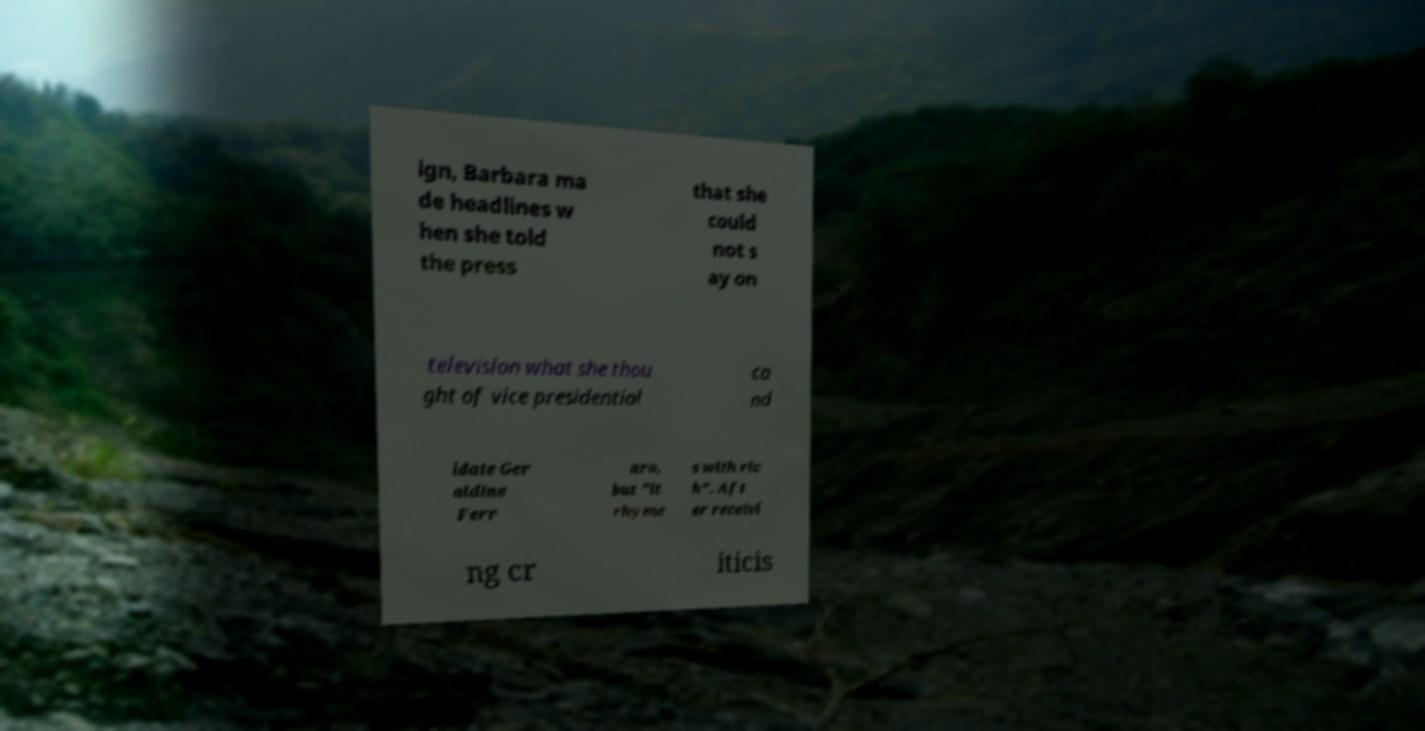Could you extract and type out the text from this image? ign, Barbara ma de headlines w hen she told the press that she could not s ay on television what she thou ght of vice presidential ca nd idate Ger aldine Ferr aro, but "it rhyme s with ric h". Aft er receivi ng cr iticis 